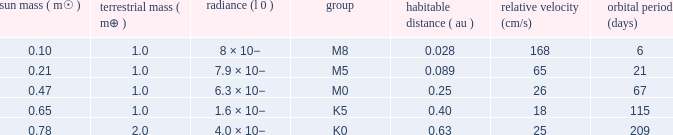What is the highest planetary mass having an RV (cm/s) of 65 and a Period (days) less than 21? None. 